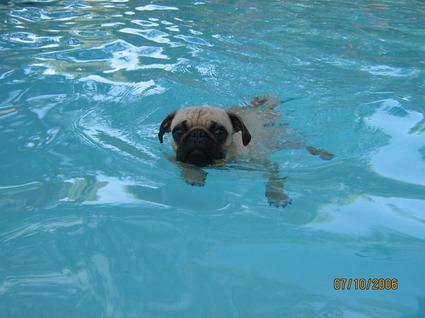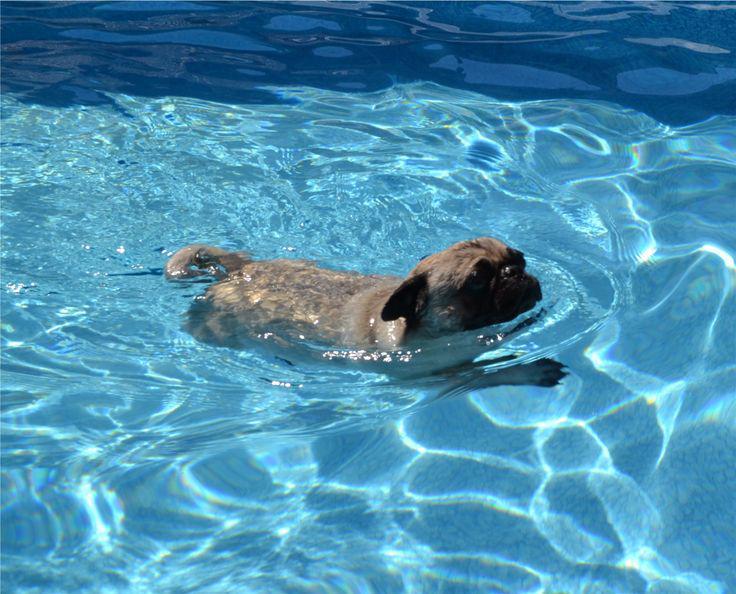The first image is the image on the left, the second image is the image on the right. Given the left and right images, does the statement "Two small dogs with pudgy noses and downturned ears are in a swimming pool aided by a floatation device." hold true? Answer yes or no. No. The first image is the image on the left, the second image is the image on the right. Examine the images to the left and right. Is the description "An image shows a rightward facing dog in a pool with no flotation device." accurate? Answer yes or no. Yes. 